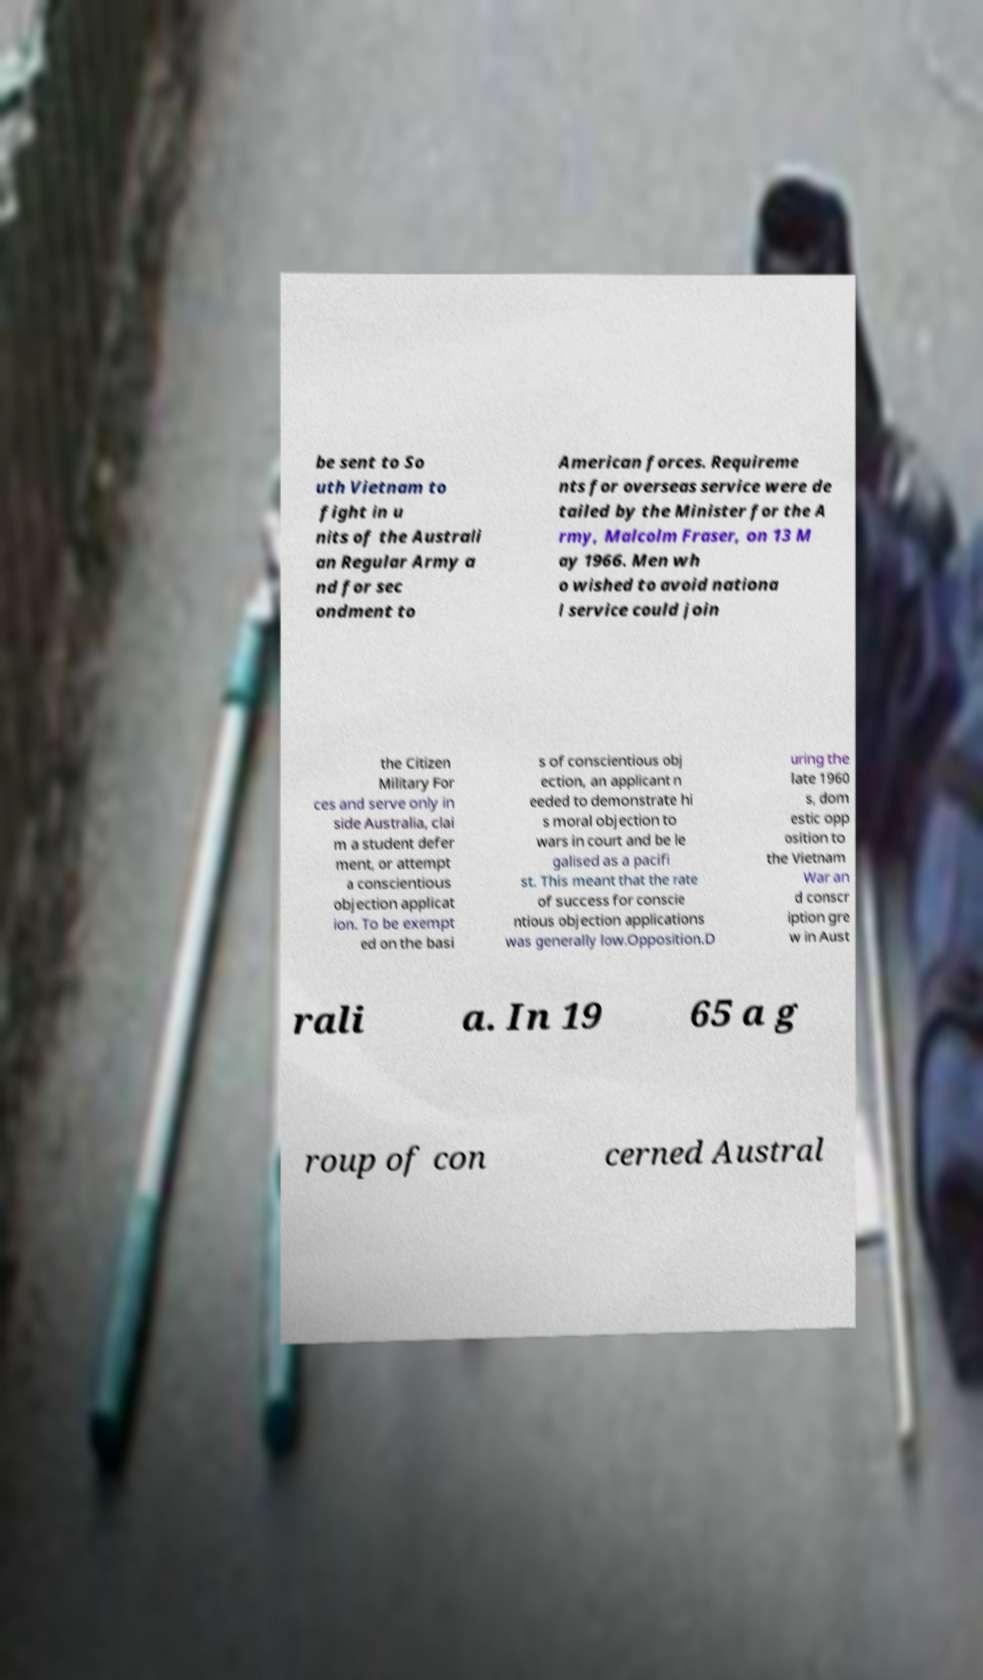What messages or text are displayed in this image? I need them in a readable, typed format. be sent to So uth Vietnam to fight in u nits of the Australi an Regular Army a nd for sec ondment to American forces. Requireme nts for overseas service were de tailed by the Minister for the A rmy, Malcolm Fraser, on 13 M ay 1966. Men wh o wished to avoid nationa l service could join the Citizen Military For ces and serve only in side Australia, clai m a student defer ment, or attempt a conscientious objection applicat ion. To be exempt ed on the basi s of conscientious obj ection, an applicant n eeded to demonstrate hi s moral objection to wars in court and be le galised as a pacifi st. This meant that the rate of success for conscie ntious objection applications was generally low.Opposition.D uring the late 1960 s, dom estic opp osition to the Vietnam War an d conscr iption gre w in Aust rali a. In 19 65 a g roup of con cerned Austral 